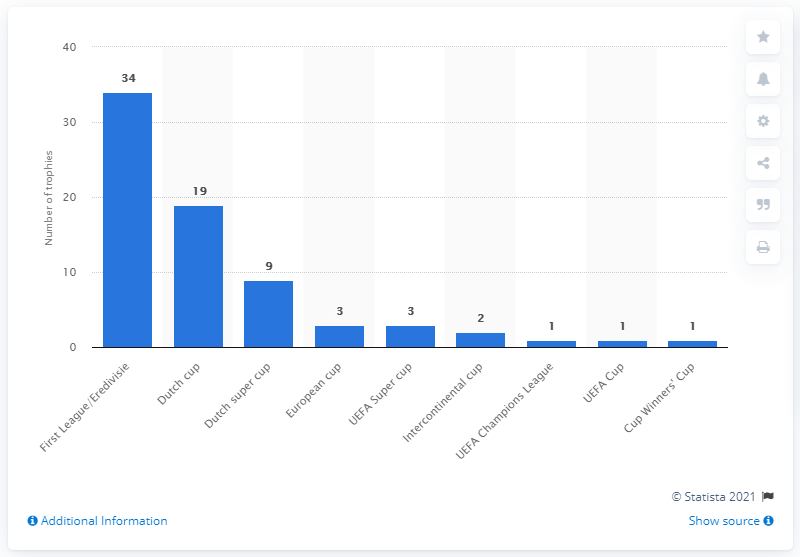List a handful of essential elements in this visual. As of August 2020, AFC Ajax had won a total of 34 league titles. 